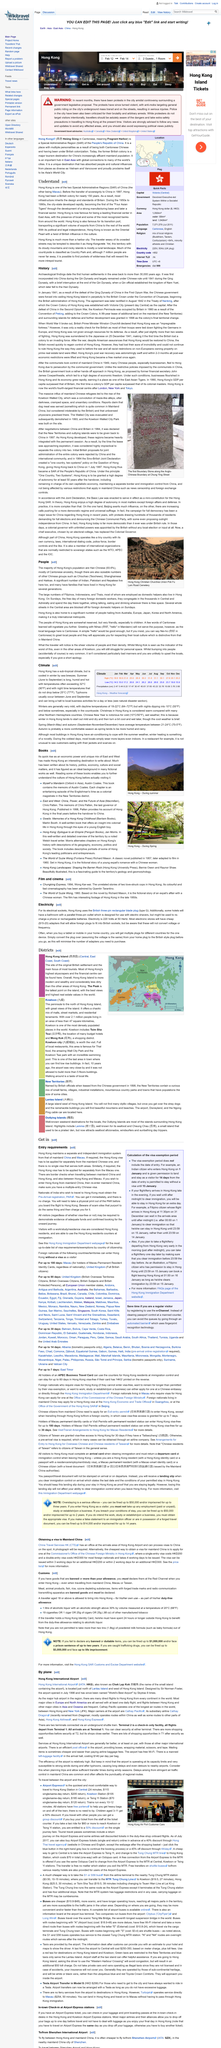Outline some significant characteristics in this image. Austin Coates is the author of the book, 'Myself a Mandarin,' Summer in Hong Kong takes place from June to September, as per the conventional timing. The photo depicts a scene from Hong Kong during the summer season, with the caption providing additional information about the location and time period captured in the image. Typhoons that bring a halt to local business activities for a day or less typically occur between June and September, typically causing disruptions to the local economy. What is known for being cold and wet? Chinese New Year is known for being cold and wet... 